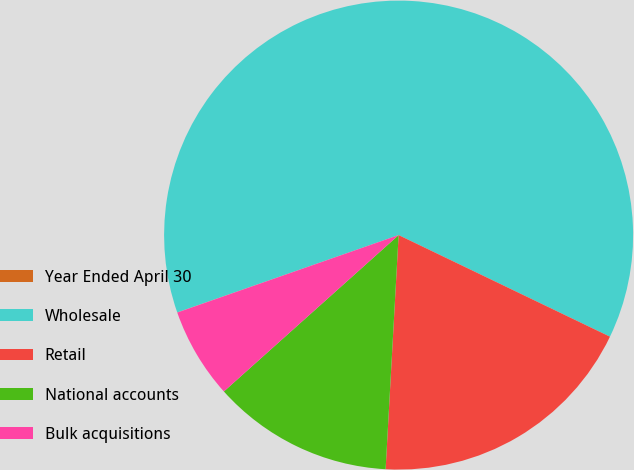Convert chart to OTSL. <chart><loc_0><loc_0><loc_500><loc_500><pie_chart><fcel>Year Ended April 30<fcel>Wholesale<fcel>Retail<fcel>National accounts<fcel>Bulk acquisitions<nl><fcel>0.01%<fcel>62.48%<fcel>18.75%<fcel>12.5%<fcel>6.26%<nl></chart> 